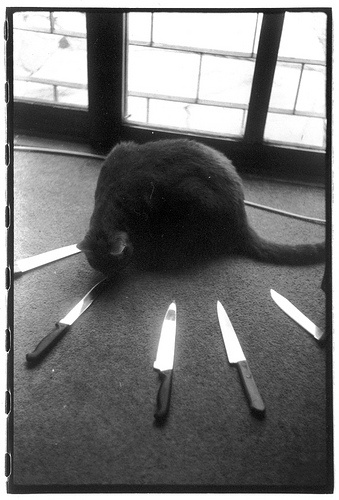Describe the objects in this image and their specific colors. I can see cat in white, black, gray, and lightgray tones, knife in white, gray, and black tones, knife in white, black, gray, and darkgray tones, knife in white, gray, black, whitesmoke, and darkgray tones, and knife in white, gray, darkgray, and black tones in this image. 